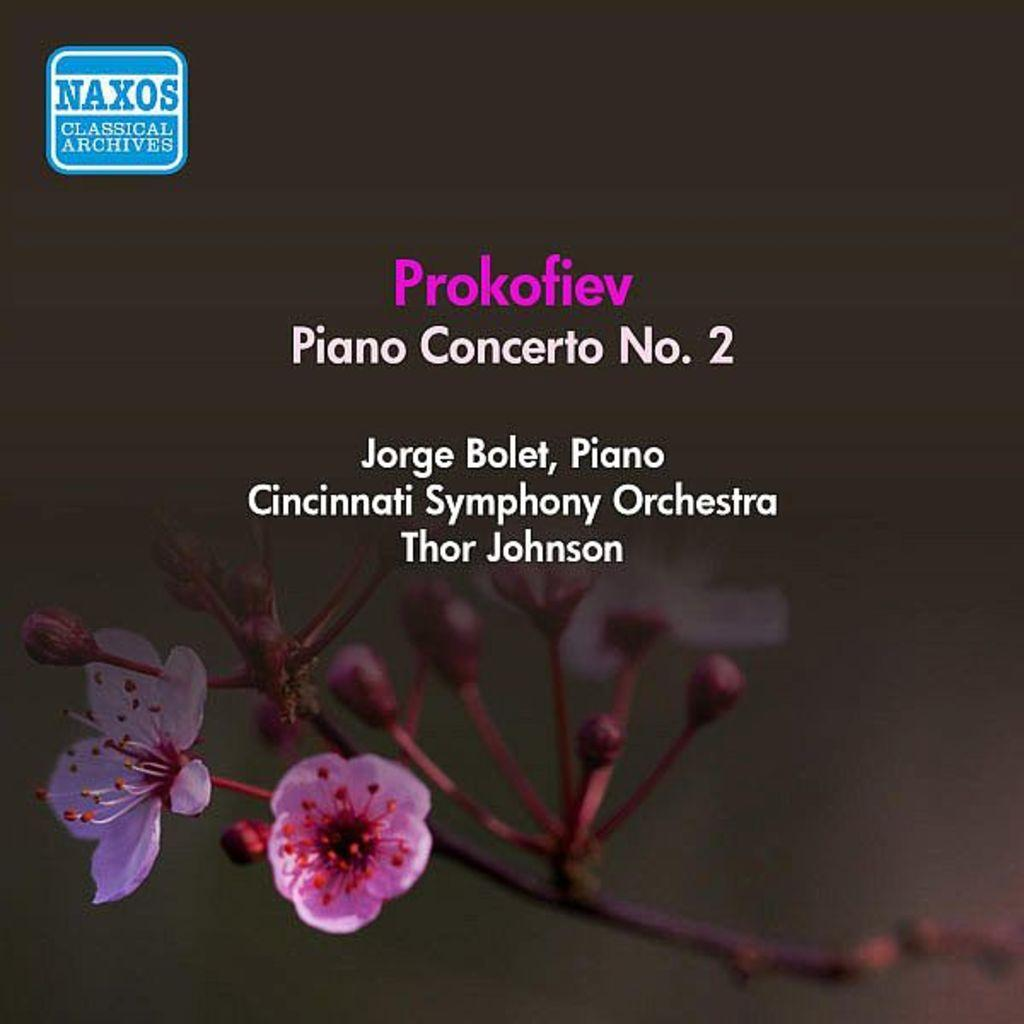<image>
Share a concise interpretation of the image provided. An advertisement for Piano Concerto No. 2 put on by the Cincinnati Symphony Orchestra. 